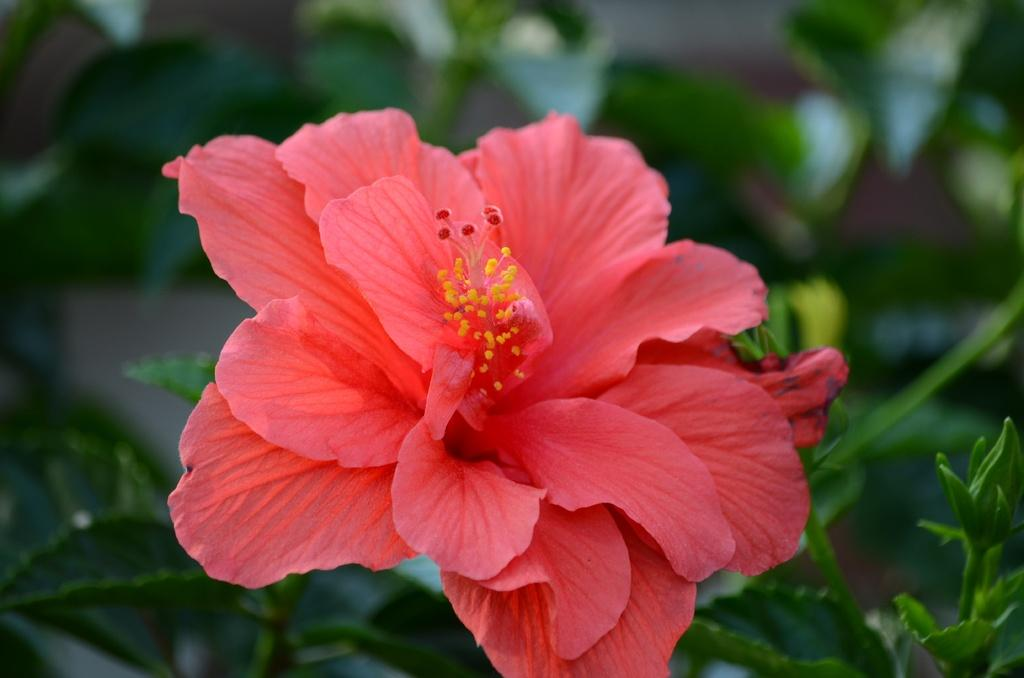What color is the flower in the image? The flower in the image is pink. What other elements can be seen in the image besides the flower? There are green leaves in the image. What type of collar is the flower wearing in the image? There is no collar present in the image, as flowers do not wear collars. 